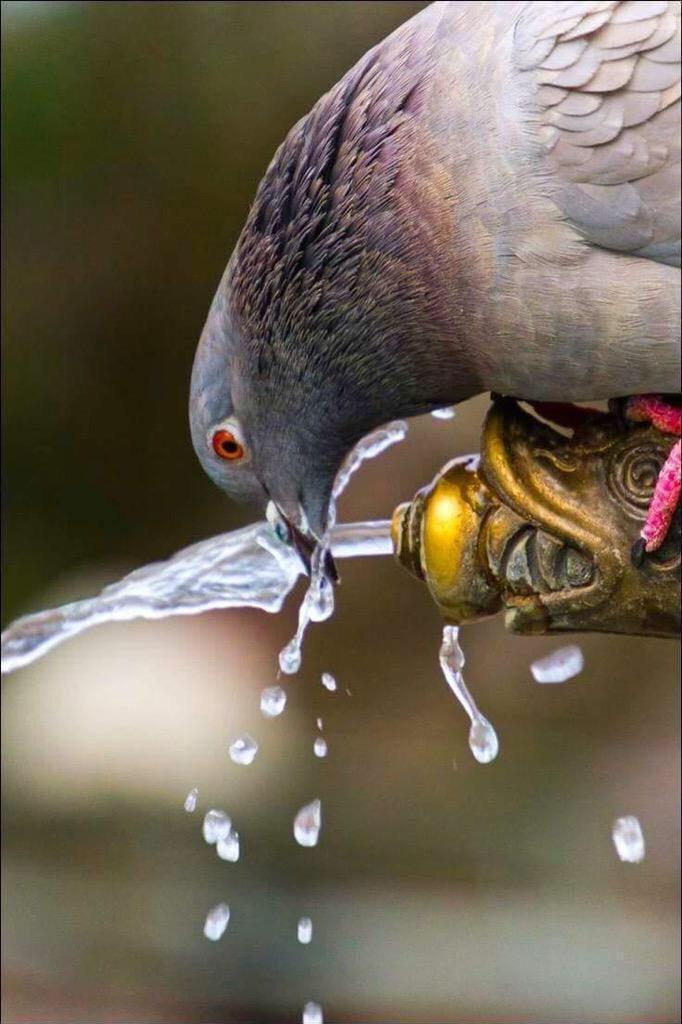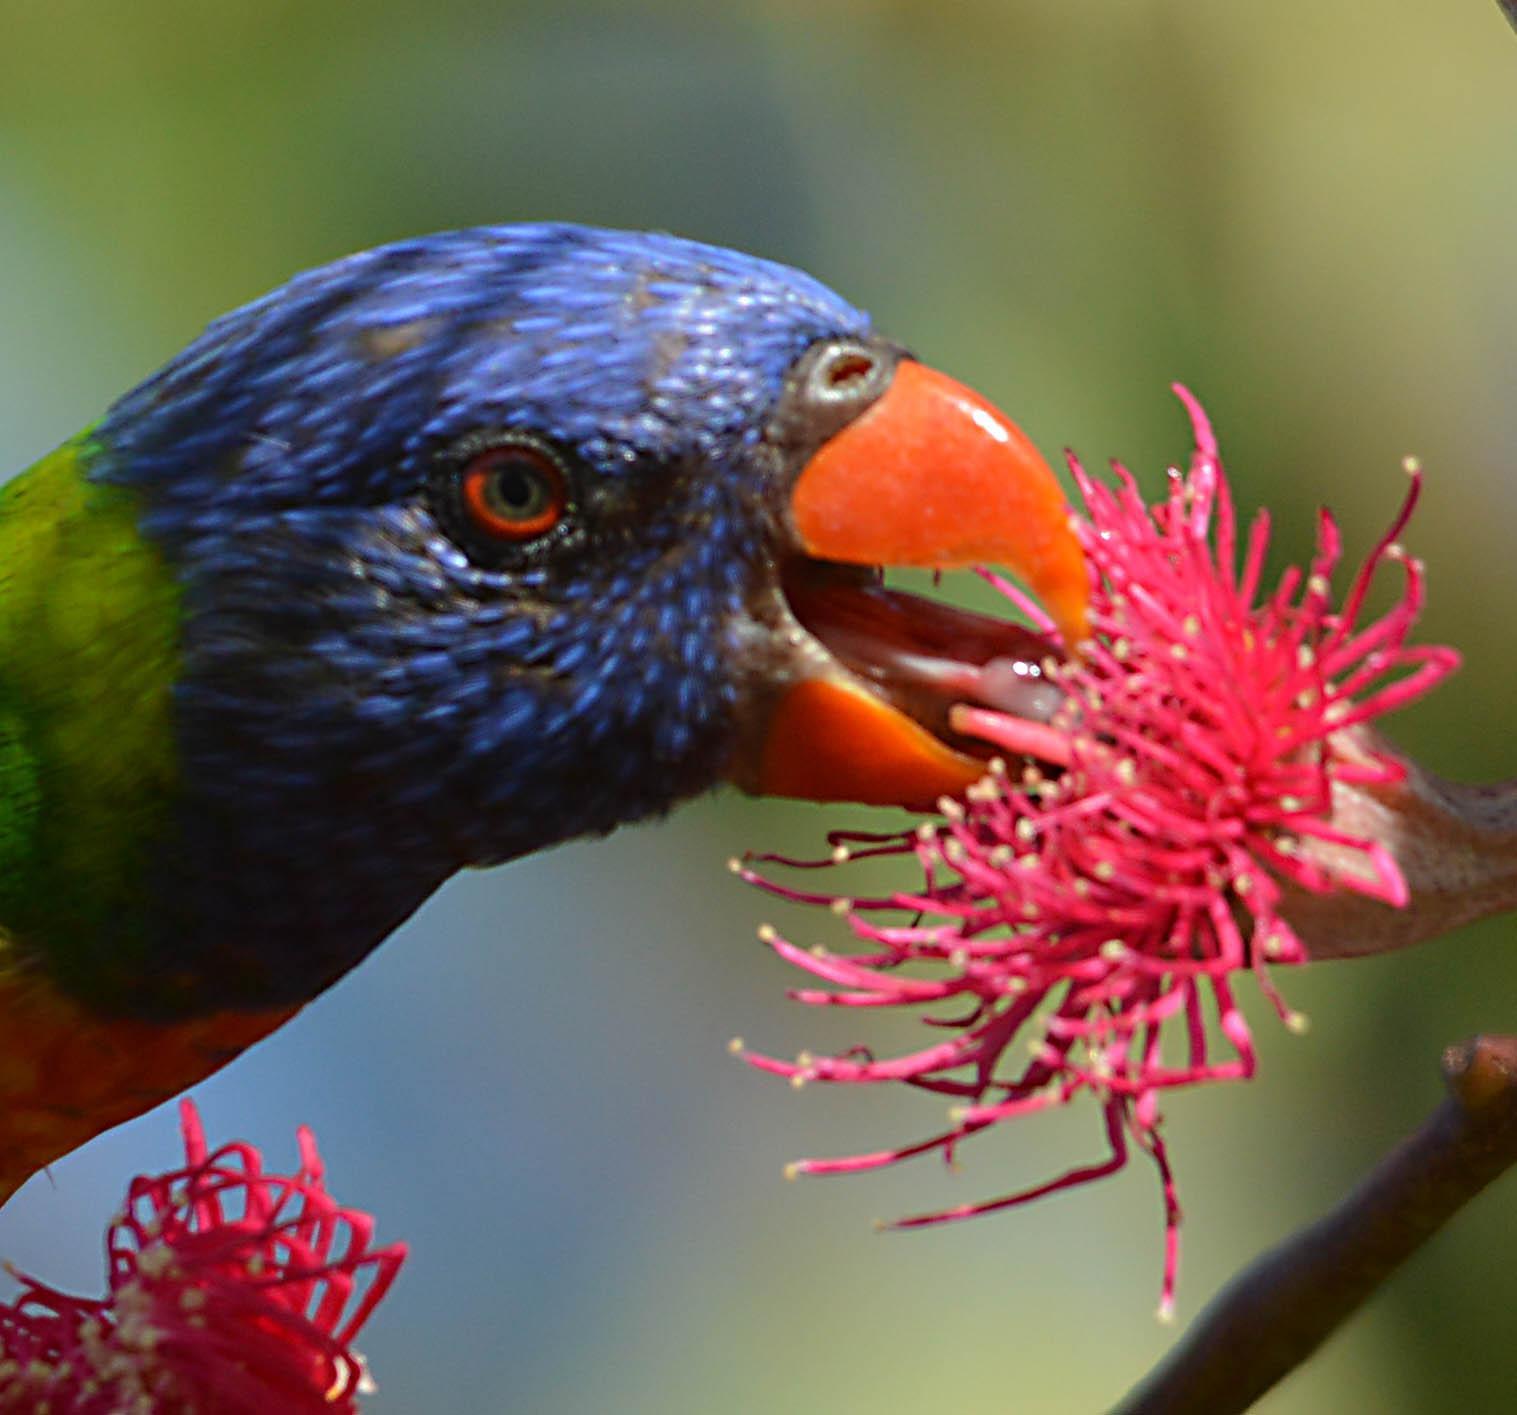The first image is the image on the left, the second image is the image on the right. Assess this claim about the two images: "There are at least two colorful parrots in the right image.". Correct or not? Answer yes or no. No. The first image is the image on the left, the second image is the image on the right. Given the left and right images, does the statement "Each image contains a single bird, and at least one bird is pictured near a flower with tendril-like petals." hold true? Answer yes or no. Yes. 